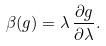<formula> <loc_0><loc_0><loc_500><loc_500>\beta ( g ) = \lambda \, { \frac { \partial g } { \partial \lambda } } .</formula> 